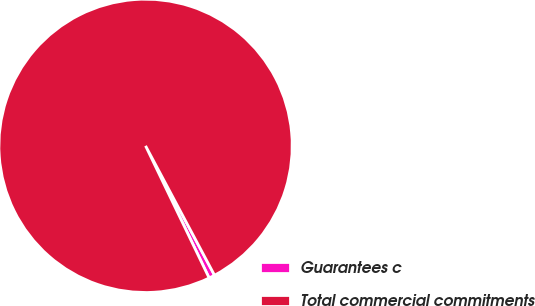Convert chart to OTSL. <chart><loc_0><loc_0><loc_500><loc_500><pie_chart><fcel>Guarantees c<fcel>Total commercial commitments<nl><fcel>0.66%<fcel>99.34%<nl></chart> 